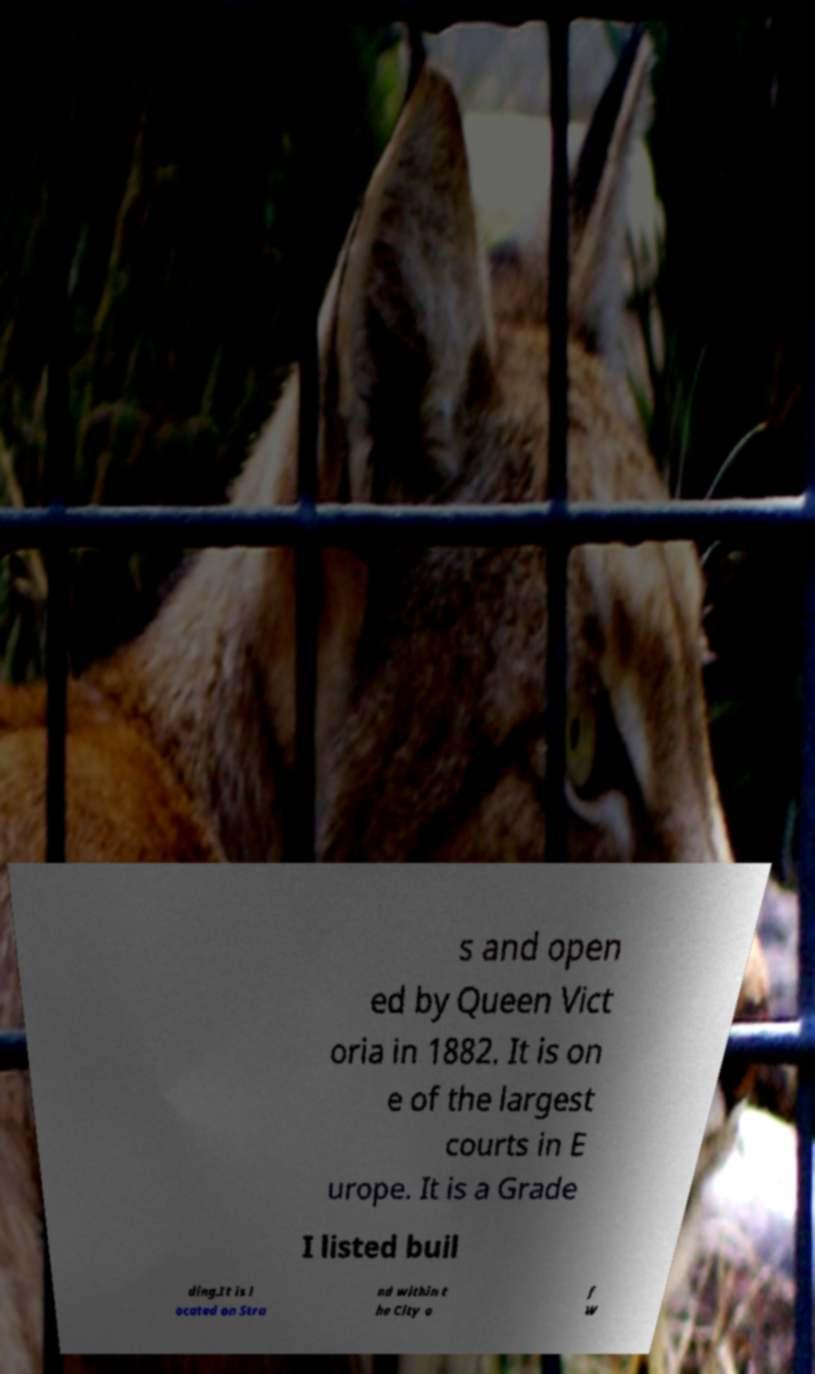Could you assist in decoding the text presented in this image and type it out clearly? s and open ed by Queen Vict oria in 1882. It is on e of the largest courts in E urope. It is a Grade I listed buil ding.It is l ocated on Stra nd within t he City o f W 